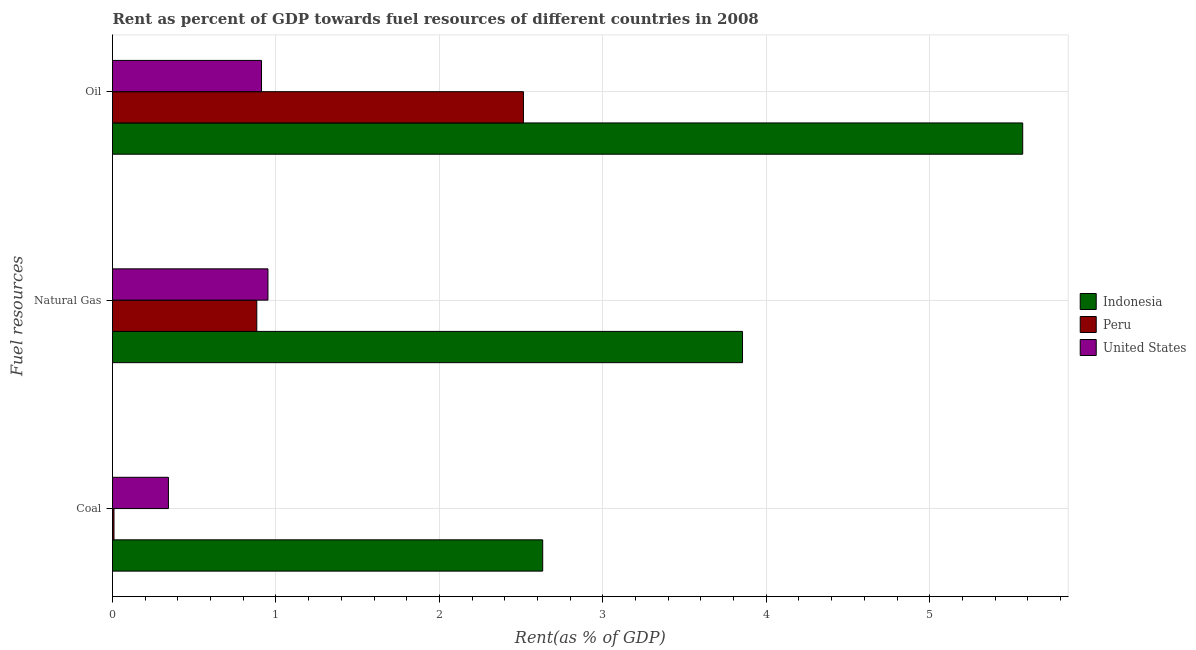How many different coloured bars are there?
Your answer should be compact. 3. Are the number of bars on each tick of the Y-axis equal?
Provide a short and direct response. Yes. How many bars are there on the 1st tick from the bottom?
Provide a short and direct response. 3. What is the label of the 2nd group of bars from the top?
Your answer should be very brief. Natural Gas. What is the rent towards natural gas in Peru?
Your answer should be very brief. 0.88. Across all countries, what is the maximum rent towards oil?
Give a very brief answer. 5.57. Across all countries, what is the minimum rent towards coal?
Your answer should be compact. 0.01. In which country was the rent towards coal minimum?
Your answer should be very brief. Peru. What is the total rent towards oil in the graph?
Provide a succinct answer. 8.99. What is the difference between the rent towards oil in Indonesia and that in United States?
Offer a very short reply. 4.66. What is the difference between the rent towards natural gas in United States and the rent towards coal in Indonesia?
Keep it short and to the point. -1.68. What is the average rent towards natural gas per country?
Keep it short and to the point. 1.9. What is the difference between the rent towards natural gas and rent towards oil in Peru?
Make the answer very short. -1.63. What is the ratio of the rent towards oil in United States to that in Peru?
Offer a very short reply. 0.36. Is the rent towards oil in United States less than that in Indonesia?
Provide a short and direct response. Yes. Is the difference between the rent towards oil in Indonesia and United States greater than the difference between the rent towards coal in Indonesia and United States?
Your answer should be compact. Yes. What is the difference between the highest and the second highest rent towards oil?
Offer a very short reply. 3.05. What is the difference between the highest and the lowest rent towards natural gas?
Your answer should be compact. 2.97. In how many countries, is the rent towards coal greater than the average rent towards coal taken over all countries?
Provide a succinct answer. 1. Is the sum of the rent towards coal in Peru and Indonesia greater than the maximum rent towards natural gas across all countries?
Provide a succinct answer. No. What does the 3rd bar from the bottom in Natural Gas represents?
Provide a succinct answer. United States. How many bars are there?
Your answer should be compact. 9. Are all the bars in the graph horizontal?
Your response must be concise. Yes. How many countries are there in the graph?
Your answer should be very brief. 3. Are the values on the major ticks of X-axis written in scientific E-notation?
Keep it short and to the point. No. Does the graph contain grids?
Your response must be concise. Yes. Where does the legend appear in the graph?
Make the answer very short. Center right. How many legend labels are there?
Give a very brief answer. 3. What is the title of the graph?
Ensure brevity in your answer.  Rent as percent of GDP towards fuel resources of different countries in 2008. Does "Pakistan" appear as one of the legend labels in the graph?
Provide a short and direct response. No. What is the label or title of the X-axis?
Offer a very short reply. Rent(as % of GDP). What is the label or title of the Y-axis?
Your response must be concise. Fuel resources. What is the Rent(as % of GDP) of Indonesia in Coal?
Offer a very short reply. 2.63. What is the Rent(as % of GDP) of Peru in Coal?
Make the answer very short. 0.01. What is the Rent(as % of GDP) of United States in Coal?
Keep it short and to the point. 0.34. What is the Rent(as % of GDP) in Indonesia in Natural Gas?
Your answer should be very brief. 3.85. What is the Rent(as % of GDP) in Peru in Natural Gas?
Offer a very short reply. 0.88. What is the Rent(as % of GDP) of United States in Natural Gas?
Offer a terse response. 0.95. What is the Rent(as % of GDP) of Indonesia in Oil?
Provide a short and direct response. 5.57. What is the Rent(as % of GDP) of Peru in Oil?
Provide a succinct answer. 2.51. What is the Rent(as % of GDP) in United States in Oil?
Your response must be concise. 0.91. Across all Fuel resources, what is the maximum Rent(as % of GDP) in Indonesia?
Give a very brief answer. 5.57. Across all Fuel resources, what is the maximum Rent(as % of GDP) of Peru?
Ensure brevity in your answer.  2.51. Across all Fuel resources, what is the maximum Rent(as % of GDP) of United States?
Provide a succinct answer. 0.95. Across all Fuel resources, what is the minimum Rent(as % of GDP) in Indonesia?
Give a very brief answer. 2.63. Across all Fuel resources, what is the minimum Rent(as % of GDP) in Peru?
Provide a short and direct response. 0.01. Across all Fuel resources, what is the minimum Rent(as % of GDP) in United States?
Keep it short and to the point. 0.34. What is the total Rent(as % of GDP) in Indonesia in the graph?
Your answer should be compact. 12.06. What is the total Rent(as % of GDP) of Peru in the graph?
Your answer should be compact. 3.41. What is the total Rent(as % of GDP) of United States in the graph?
Provide a succinct answer. 2.2. What is the difference between the Rent(as % of GDP) of Indonesia in Coal and that in Natural Gas?
Your response must be concise. -1.22. What is the difference between the Rent(as % of GDP) of Peru in Coal and that in Natural Gas?
Offer a very short reply. -0.87. What is the difference between the Rent(as % of GDP) in United States in Coal and that in Natural Gas?
Ensure brevity in your answer.  -0.61. What is the difference between the Rent(as % of GDP) of Indonesia in Coal and that in Oil?
Your response must be concise. -2.94. What is the difference between the Rent(as % of GDP) in Peru in Coal and that in Oil?
Ensure brevity in your answer.  -2.51. What is the difference between the Rent(as % of GDP) of United States in Coal and that in Oil?
Ensure brevity in your answer.  -0.57. What is the difference between the Rent(as % of GDP) in Indonesia in Natural Gas and that in Oil?
Offer a very short reply. -1.71. What is the difference between the Rent(as % of GDP) of Peru in Natural Gas and that in Oil?
Provide a succinct answer. -1.63. What is the difference between the Rent(as % of GDP) of United States in Natural Gas and that in Oil?
Offer a terse response. 0.04. What is the difference between the Rent(as % of GDP) in Indonesia in Coal and the Rent(as % of GDP) in Peru in Natural Gas?
Your answer should be very brief. 1.75. What is the difference between the Rent(as % of GDP) of Indonesia in Coal and the Rent(as % of GDP) of United States in Natural Gas?
Offer a terse response. 1.68. What is the difference between the Rent(as % of GDP) in Peru in Coal and the Rent(as % of GDP) in United States in Natural Gas?
Your answer should be compact. -0.94. What is the difference between the Rent(as % of GDP) in Indonesia in Coal and the Rent(as % of GDP) in Peru in Oil?
Your answer should be compact. 0.12. What is the difference between the Rent(as % of GDP) in Indonesia in Coal and the Rent(as % of GDP) in United States in Oil?
Ensure brevity in your answer.  1.72. What is the difference between the Rent(as % of GDP) in Peru in Coal and the Rent(as % of GDP) in United States in Oil?
Your answer should be compact. -0.9. What is the difference between the Rent(as % of GDP) in Indonesia in Natural Gas and the Rent(as % of GDP) in Peru in Oil?
Offer a terse response. 1.34. What is the difference between the Rent(as % of GDP) of Indonesia in Natural Gas and the Rent(as % of GDP) of United States in Oil?
Provide a succinct answer. 2.94. What is the difference between the Rent(as % of GDP) of Peru in Natural Gas and the Rent(as % of GDP) of United States in Oil?
Ensure brevity in your answer.  -0.03. What is the average Rent(as % of GDP) in Indonesia per Fuel resources?
Your answer should be compact. 4.02. What is the average Rent(as % of GDP) of Peru per Fuel resources?
Provide a succinct answer. 1.14. What is the average Rent(as % of GDP) of United States per Fuel resources?
Your response must be concise. 0.73. What is the difference between the Rent(as % of GDP) of Indonesia and Rent(as % of GDP) of Peru in Coal?
Your answer should be compact. 2.62. What is the difference between the Rent(as % of GDP) of Indonesia and Rent(as % of GDP) of United States in Coal?
Offer a very short reply. 2.29. What is the difference between the Rent(as % of GDP) in Peru and Rent(as % of GDP) in United States in Coal?
Your response must be concise. -0.33. What is the difference between the Rent(as % of GDP) in Indonesia and Rent(as % of GDP) in Peru in Natural Gas?
Your response must be concise. 2.97. What is the difference between the Rent(as % of GDP) of Indonesia and Rent(as % of GDP) of United States in Natural Gas?
Keep it short and to the point. 2.9. What is the difference between the Rent(as % of GDP) in Peru and Rent(as % of GDP) in United States in Natural Gas?
Provide a succinct answer. -0.07. What is the difference between the Rent(as % of GDP) of Indonesia and Rent(as % of GDP) of Peru in Oil?
Keep it short and to the point. 3.05. What is the difference between the Rent(as % of GDP) in Indonesia and Rent(as % of GDP) in United States in Oil?
Make the answer very short. 4.66. What is the difference between the Rent(as % of GDP) in Peru and Rent(as % of GDP) in United States in Oil?
Provide a succinct answer. 1.6. What is the ratio of the Rent(as % of GDP) of Indonesia in Coal to that in Natural Gas?
Make the answer very short. 0.68. What is the ratio of the Rent(as % of GDP) of Peru in Coal to that in Natural Gas?
Your answer should be compact. 0.01. What is the ratio of the Rent(as % of GDP) in United States in Coal to that in Natural Gas?
Provide a short and direct response. 0.36. What is the ratio of the Rent(as % of GDP) of Indonesia in Coal to that in Oil?
Provide a short and direct response. 0.47. What is the ratio of the Rent(as % of GDP) in Peru in Coal to that in Oil?
Provide a short and direct response. 0. What is the ratio of the Rent(as % of GDP) of United States in Coal to that in Oil?
Make the answer very short. 0.38. What is the ratio of the Rent(as % of GDP) in Indonesia in Natural Gas to that in Oil?
Your answer should be compact. 0.69. What is the ratio of the Rent(as % of GDP) in Peru in Natural Gas to that in Oil?
Give a very brief answer. 0.35. What is the ratio of the Rent(as % of GDP) in United States in Natural Gas to that in Oil?
Provide a short and direct response. 1.04. What is the difference between the highest and the second highest Rent(as % of GDP) in Indonesia?
Provide a succinct answer. 1.71. What is the difference between the highest and the second highest Rent(as % of GDP) of Peru?
Keep it short and to the point. 1.63. What is the difference between the highest and the second highest Rent(as % of GDP) in United States?
Offer a terse response. 0.04. What is the difference between the highest and the lowest Rent(as % of GDP) in Indonesia?
Provide a succinct answer. 2.94. What is the difference between the highest and the lowest Rent(as % of GDP) in Peru?
Your answer should be very brief. 2.51. What is the difference between the highest and the lowest Rent(as % of GDP) of United States?
Your answer should be very brief. 0.61. 